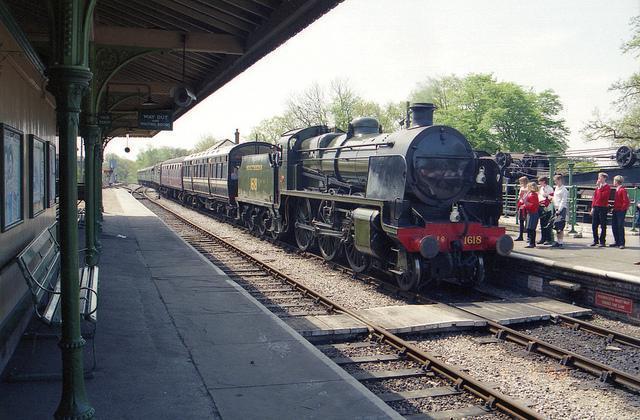How many people are on the right?
Give a very brief answer. 6. 